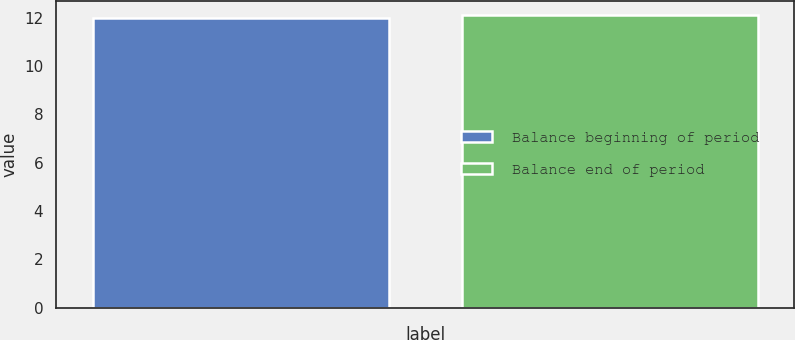Convert chart to OTSL. <chart><loc_0><loc_0><loc_500><loc_500><bar_chart><fcel>Balance beginning of period<fcel>Balance end of period<nl><fcel>12<fcel>12.1<nl></chart> 